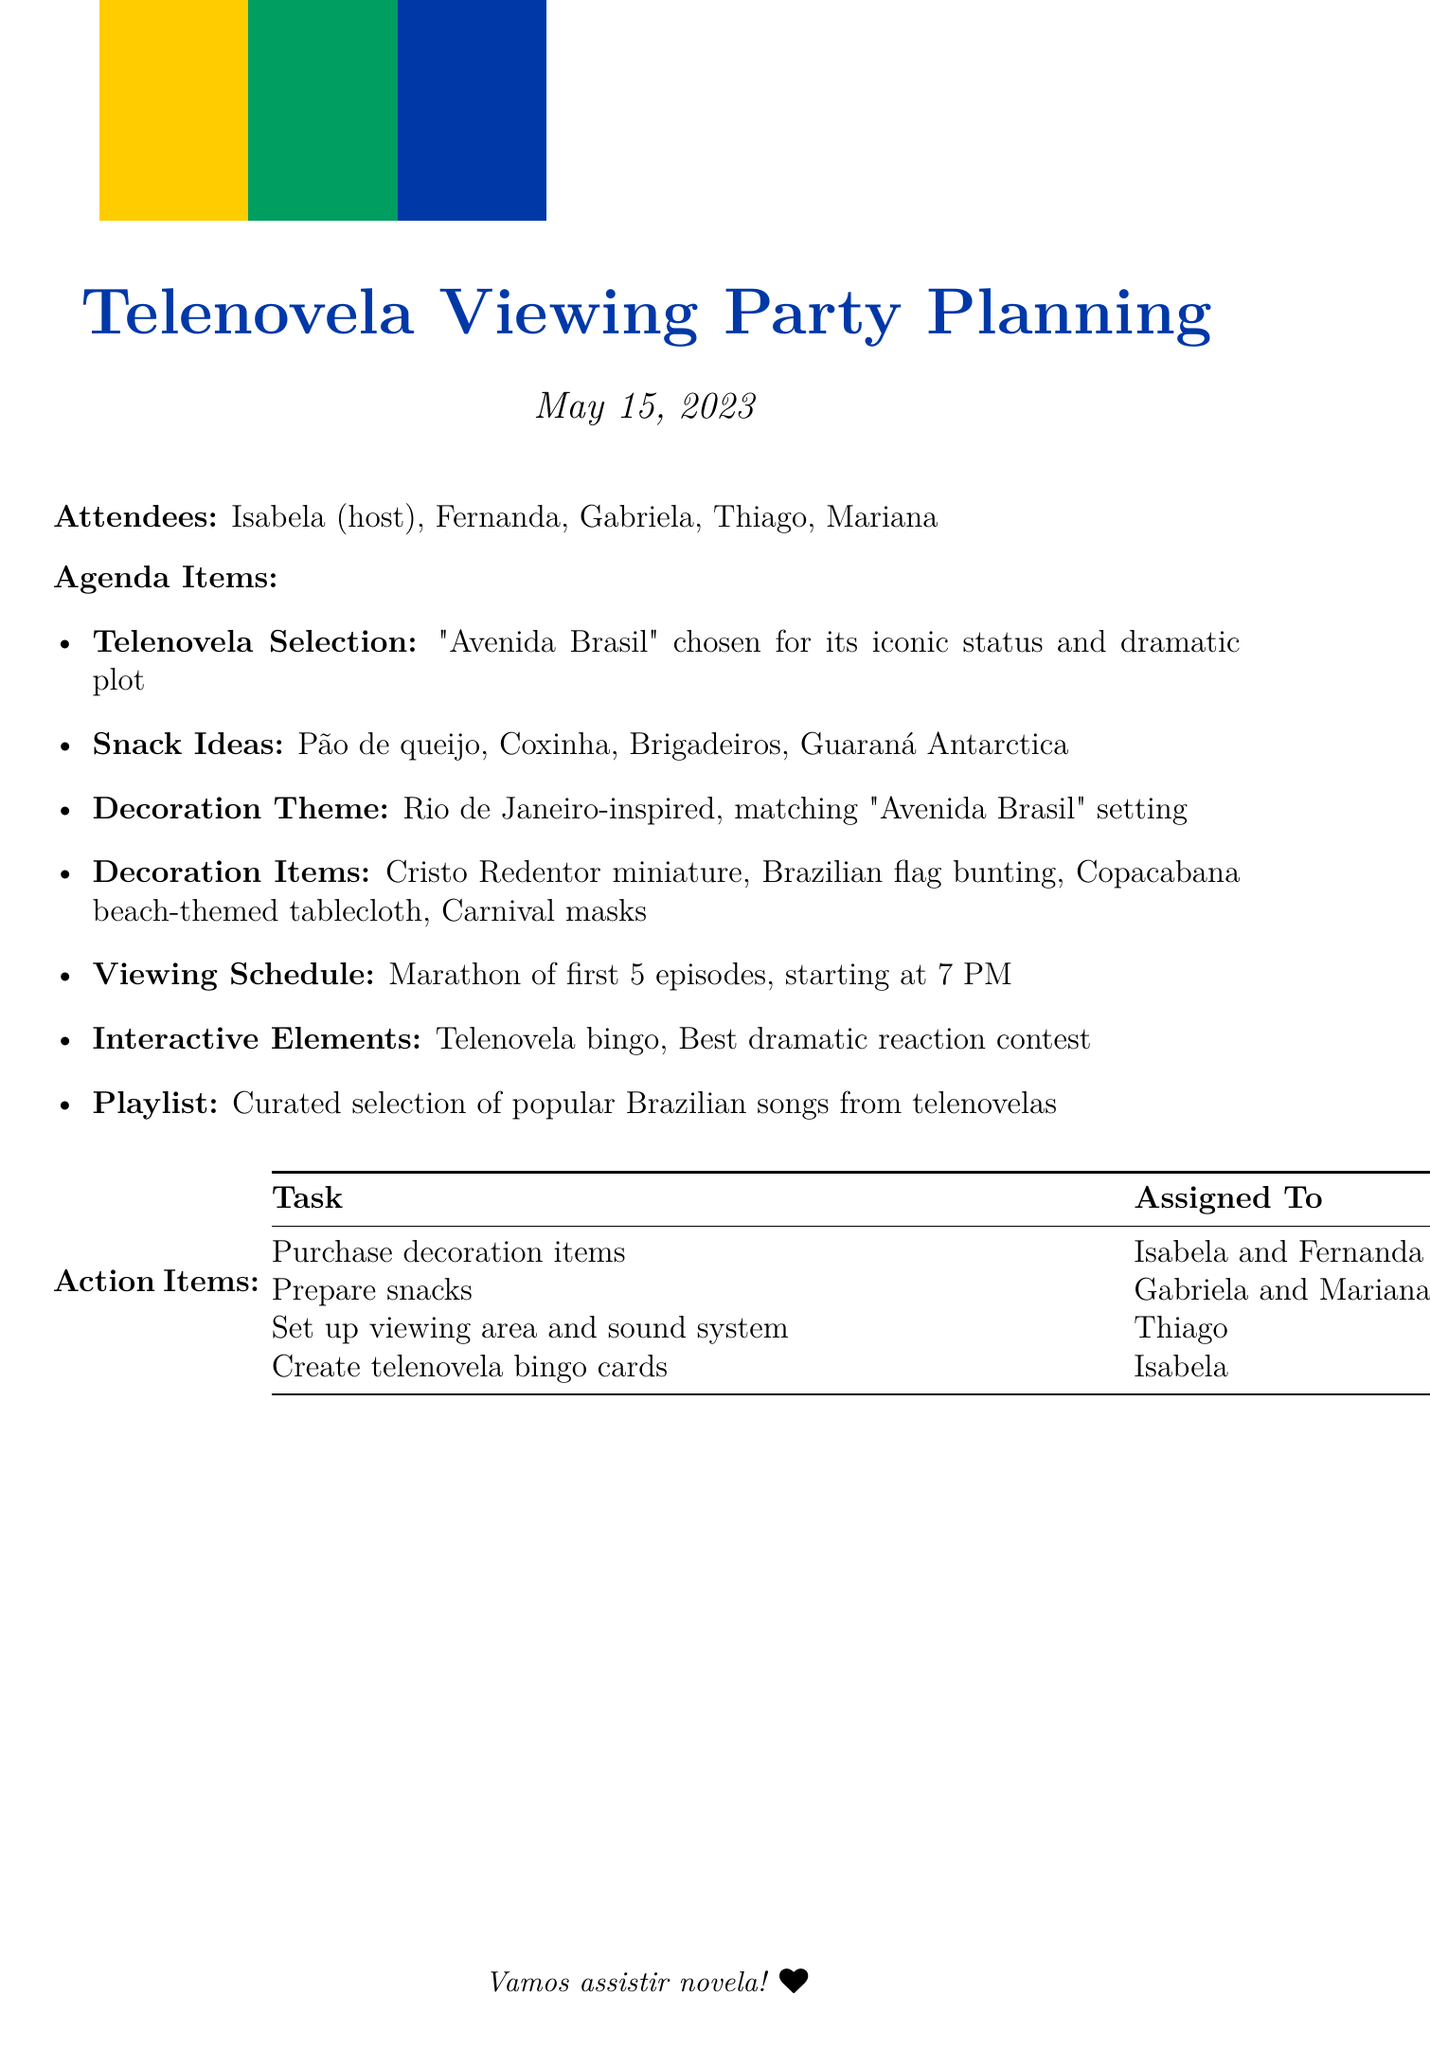What is the date of the telenovela viewing party? The date of the party is explicitly stated in the document as May 15, 2023.
Answer: May 15, 2023 Who is the host of the viewing party? The document lists Isabela as the host among the attendees.
Answer: Isabela What telenovela was chosen for the viewing party? The selected telenovela for the party is mentioned in the agenda as "Avenida Brasil".
Answer: Avenida Brasil What is one of the interactive elements planned for the party? Interactive elements are listed, and one of them is Telenovela bingo, which involves gameplay during the viewing.
Answer: Telenovela bingo Which attendees are responsible for preparing snacks? The document specifies that Gabriela and Mariana are assigned the task of preparing snacks.
Answer: Gabriela and Mariana What type of decorations are planned for the party? The decoration theme is described as Rio de Janeiro-inspired, creating a specific atmosphere that matches the telenovela's setting.
Answer: Rio de Janeiro-inspired When does the viewing marathon start? The document provides the schedule, indicating that the marathon of first 5 episodes starts at 7 PM.
Answer: 7 PM What snack is made of chicken? The document lists snacks, with Coxinha identified specifically as a chicken croquette.
Answer: Coxinha Who is tasked with creating bingo cards? The action item states that Isabela is responsible for creating the telenovela bingo cards.
Answer: Isabela 